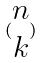<formula> <loc_0><loc_0><loc_500><loc_500>( \begin{matrix} n \\ k \end{matrix} )</formula> 